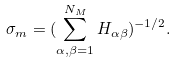Convert formula to latex. <formula><loc_0><loc_0><loc_500><loc_500>\sigma _ { m } = ( \sum _ { \alpha , \beta = 1 } ^ { N _ { M } } H _ { \alpha \beta } ) ^ { - 1 / 2 } .</formula> 